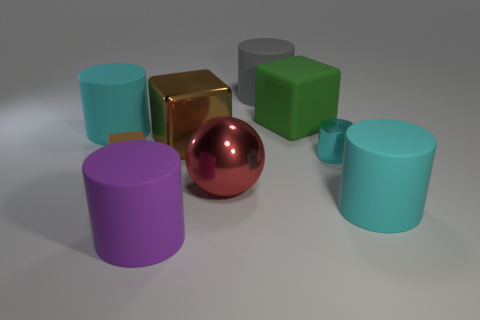What number of large things are the same color as the tiny rubber block?
Your response must be concise. 1. How many big cyan things are behind the brown metallic cube and to the right of the big matte cube?
Provide a succinct answer. 0. The small cylinder that is on the left side of the cyan thing in front of the shiny cylinder is what color?
Provide a succinct answer. Cyan. Are there an equal number of small rubber things that are right of the large purple rubber thing and tiny green rubber cylinders?
Your answer should be very brief. Yes. There is a big cyan cylinder to the left of the big cyan rubber cylinder on the right side of the gray matte cylinder; what number of cyan matte objects are on the left side of it?
Make the answer very short. 0. What color is the big cylinder that is right of the small shiny thing?
Your answer should be compact. Cyan. The large thing that is on the right side of the big brown metallic object and on the left side of the big gray rubber thing is made of what material?
Your answer should be very brief. Metal. What number of big red objects are to the left of the small object that is to the right of the large red metallic thing?
Provide a short and direct response. 1. What shape is the large green thing?
Your answer should be very brief. Cube. What shape is the big object that is made of the same material as the big brown cube?
Provide a short and direct response. Sphere. 